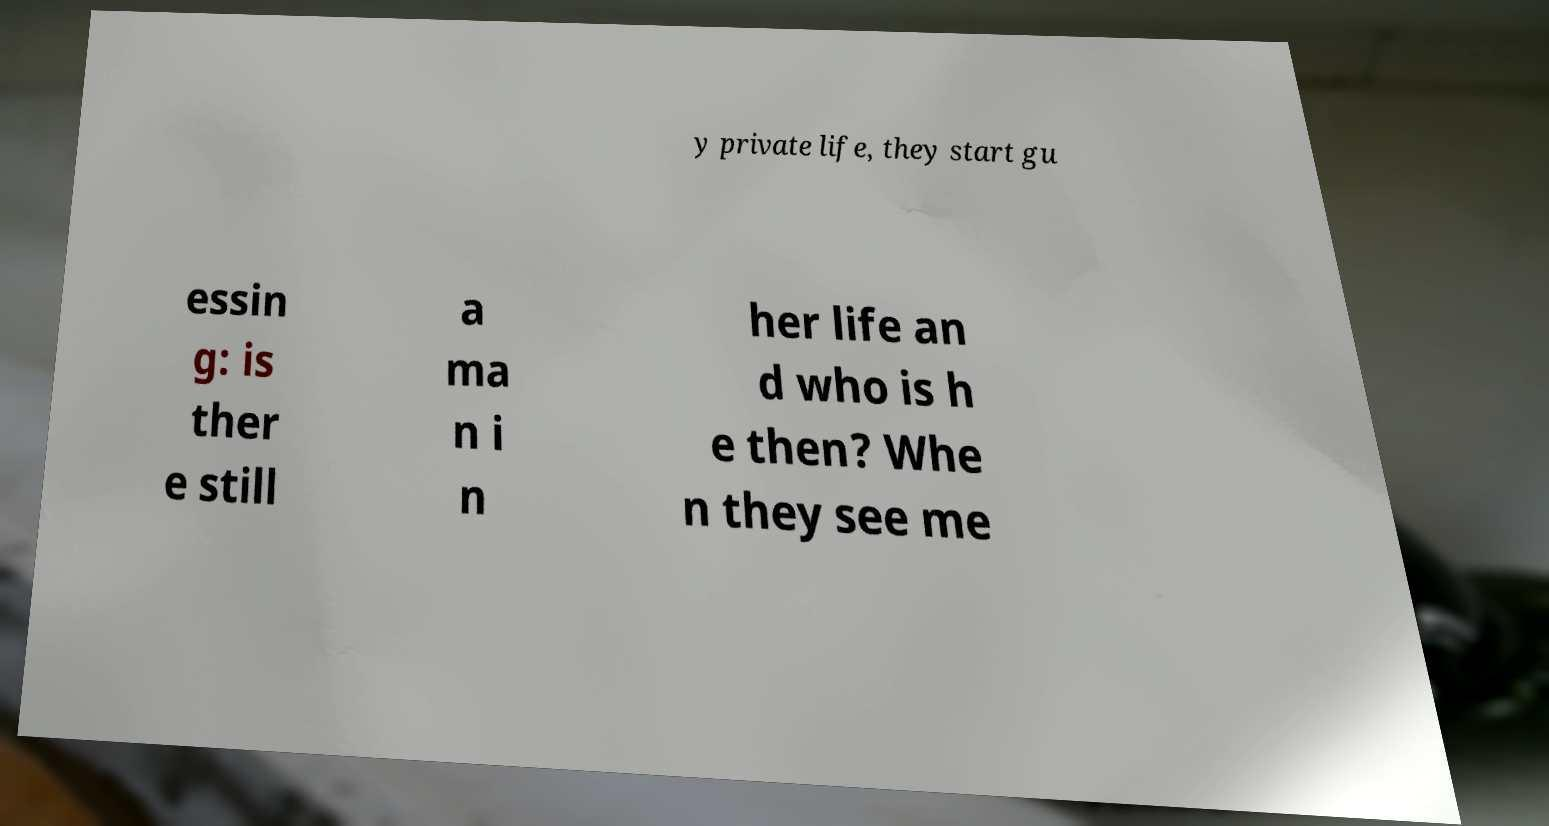Could you assist in decoding the text presented in this image and type it out clearly? y private life, they start gu essin g: is ther e still a ma n i n her life an d who is h e then? Whe n they see me 